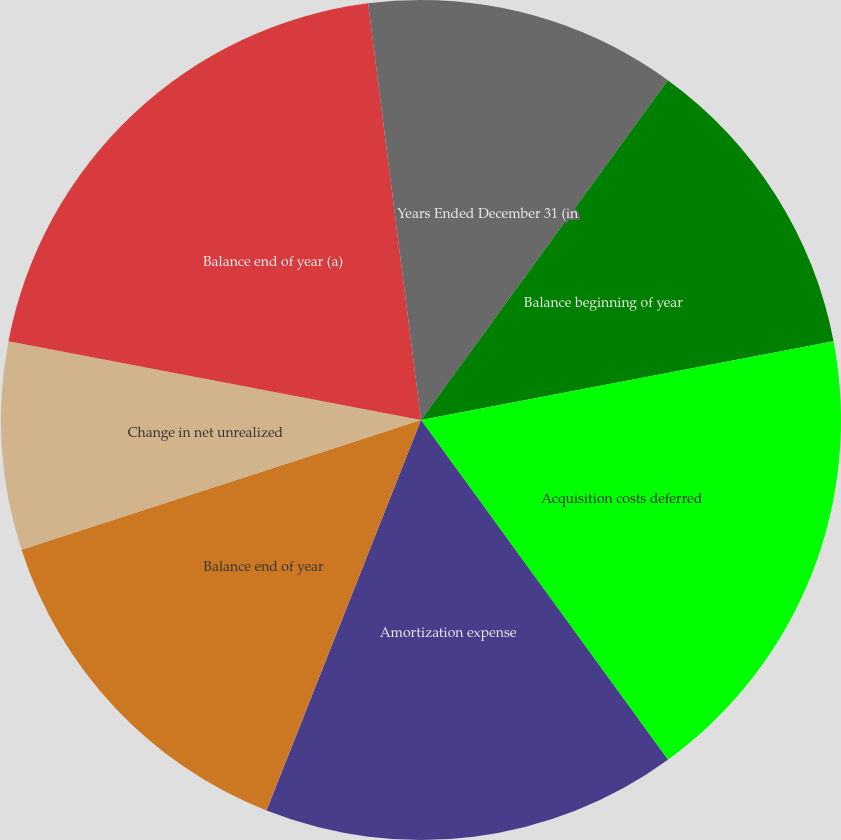<chart> <loc_0><loc_0><loc_500><loc_500><pie_chart><fcel>Years Ended December 31 (in<fcel>Balance beginning of year<fcel>Acquisition costs deferred<fcel>Amortization expense<fcel>Increase (decrease) due to<fcel>Balance end of year<fcel>Change in net unrealized<fcel>Balance end of year (a)<fcel>Subtotal<nl><fcel>10.0%<fcel>12.0%<fcel>18.0%<fcel>16.0%<fcel>0.01%<fcel>14.0%<fcel>8.0%<fcel>19.99%<fcel>2.01%<nl></chart> 